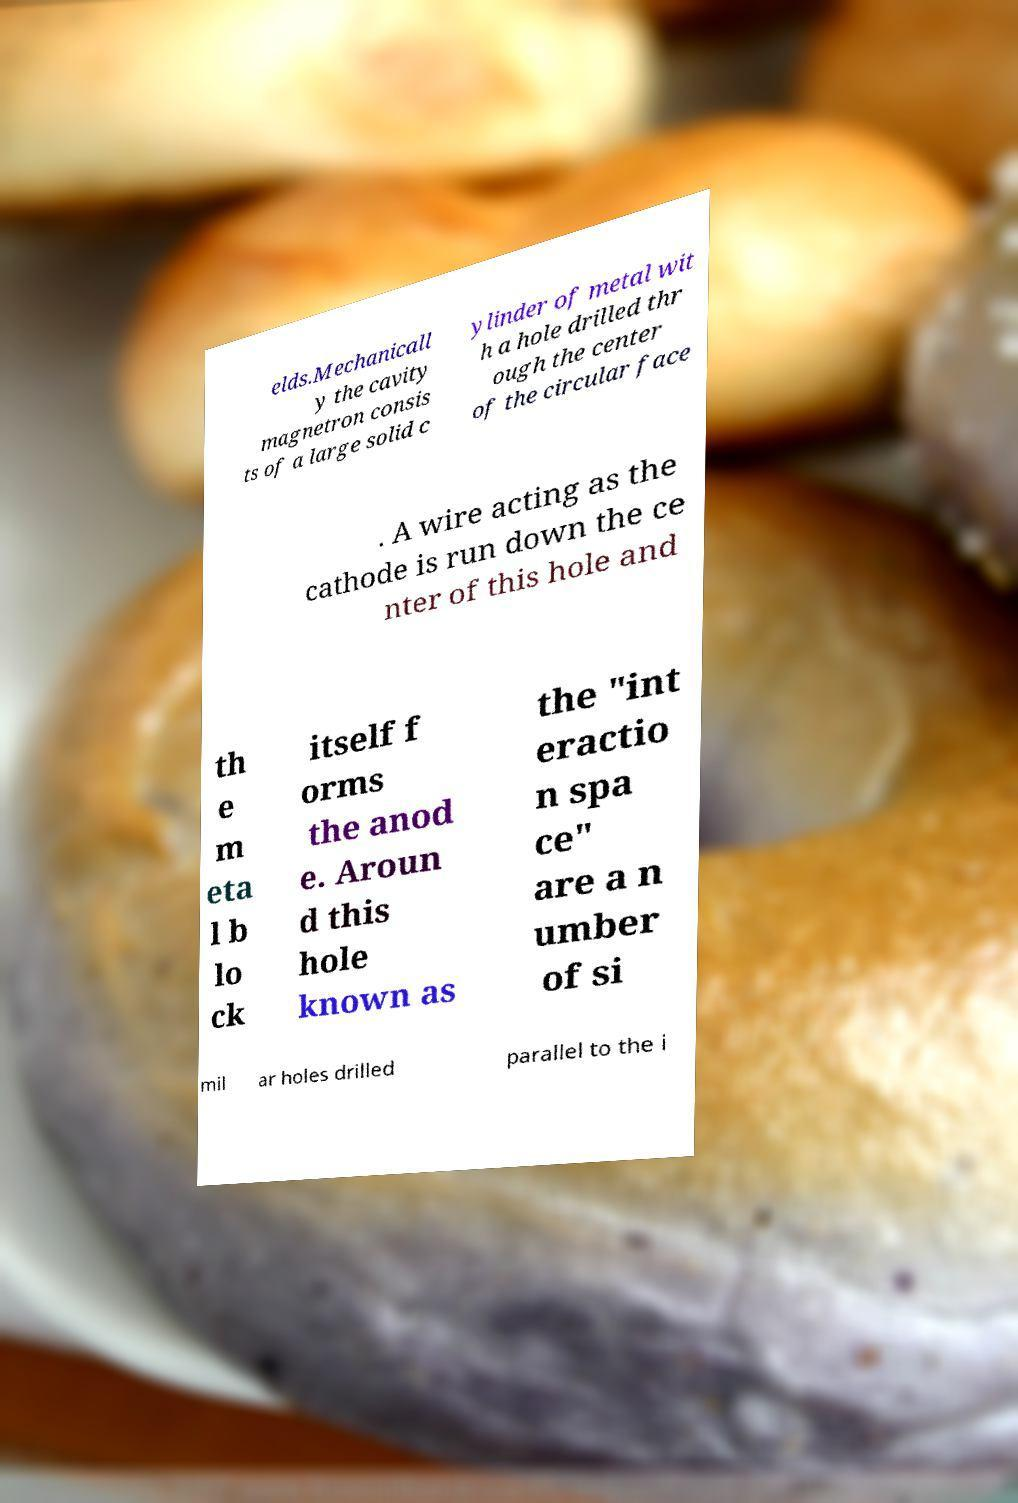Please identify and transcribe the text found in this image. elds.Mechanicall y the cavity magnetron consis ts of a large solid c ylinder of metal wit h a hole drilled thr ough the center of the circular face . A wire acting as the cathode is run down the ce nter of this hole and th e m eta l b lo ck itself f orms the anod e. Aroun d this hole known as the "int eractio n spa ce" are a n umber of si mil ar holes drilled parallel to the i 